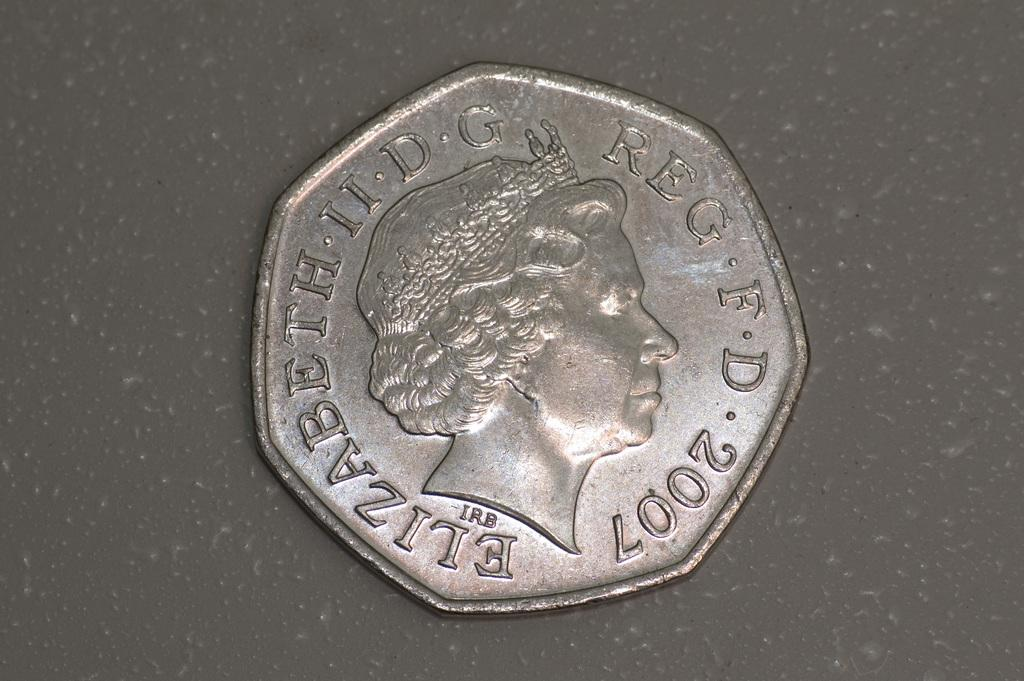<image>
Create a compact narrative representing the image presented. The british 50p piece shown here was made in 2007. 